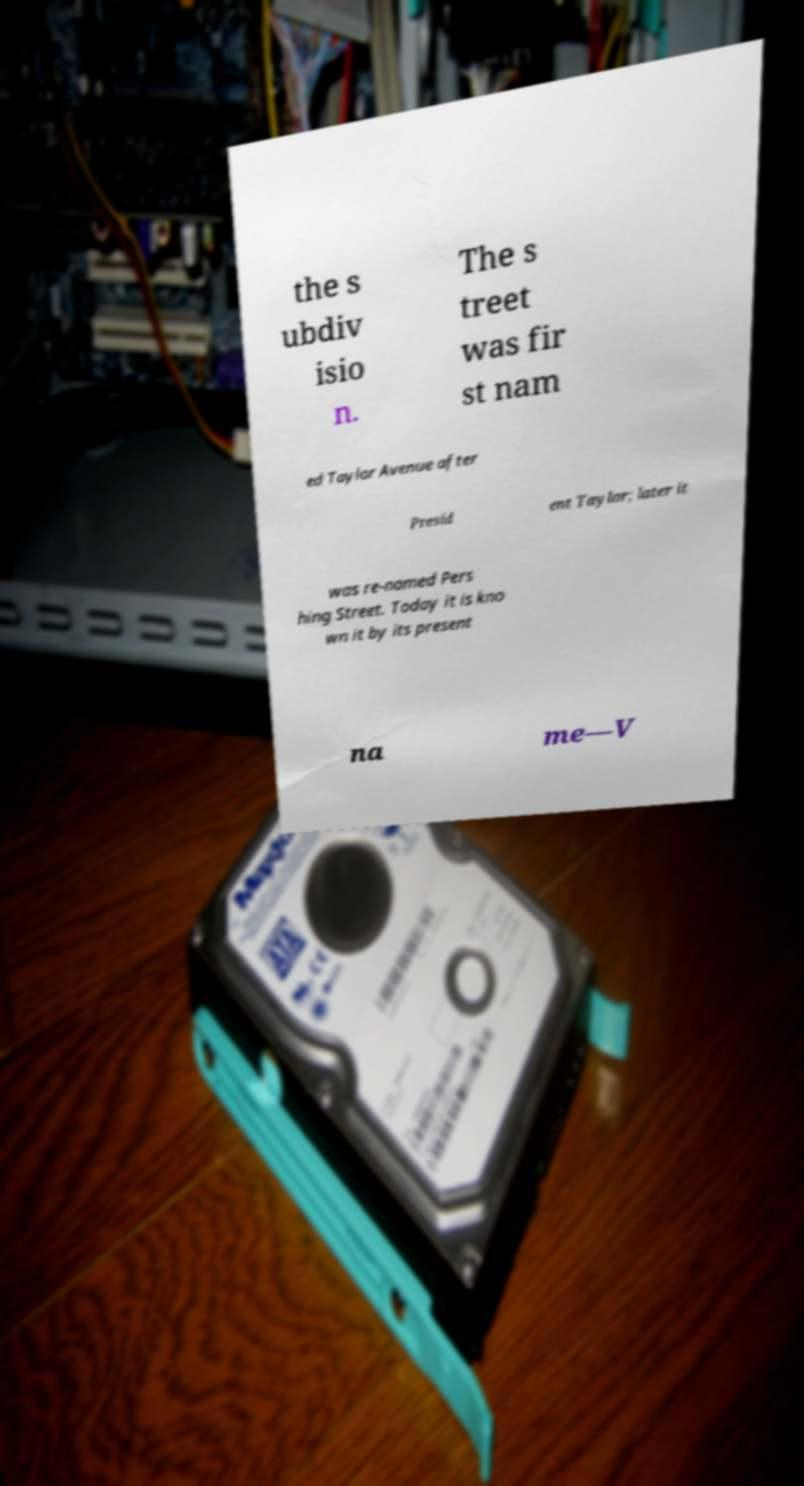For documentation purposes, I need the text within this image transcribed. Could you provide that? the s ubdiv isio n. The s treet was fir st nam ed Taylor Avenue after Presid ent Taylor; later it was re-named Pers hing Street. Today it is kno wn it by its present na me—V 